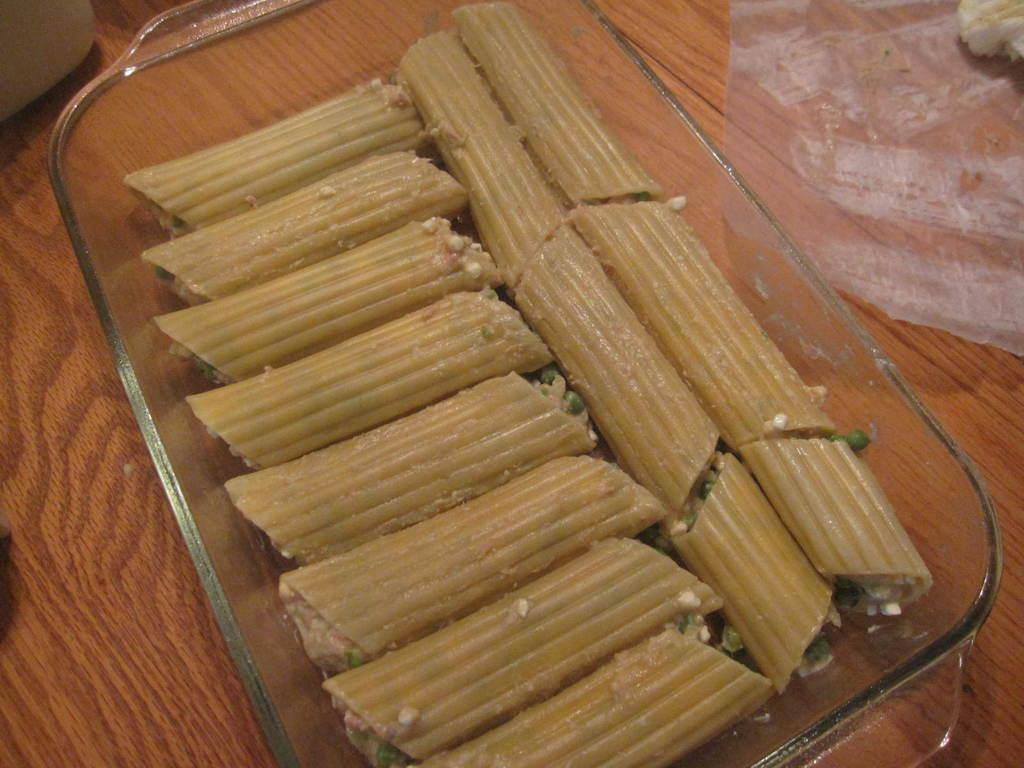What type of food item is in the glass plate in the image? The specific type of food item in the glass plate cannot be determined from the provided facts. What is the paper used for in the image? The purpose of the paper in the image cannot be determined from the provided facts. What objects are on the table in the image? The specific objects on the table in the image cannot be determined from the provided facts. What type of beast can be seen flying in the scene depicted in the image? There is no beast or scene present in the image; it only shows a food item in a glass plate, paper, and objects on a table. 